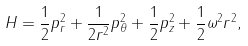Convert formula to latex. <formula><loc_0><loc_0><loc_500><loc_500>H = \frac { 1 } { 2 } p _ { r } ^ { 2 } + \frac { 1 } { 2 r ^ { 2 } } p _ { \theta } ^ { 2 } + \frac { 1 } { 2 } p _ { z } ^ { 2 } + \frac { 1 } { 2 } \omega ^ { 2 } r ^ { 2 } ,</formula> 